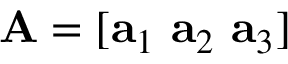Convert formula to latex. <formula><loc_0><loc_0><loc_500><loc_500>A = [ a _ { 1 } \ a _ { 2 } \ a _ { 3 } ]</formula> 